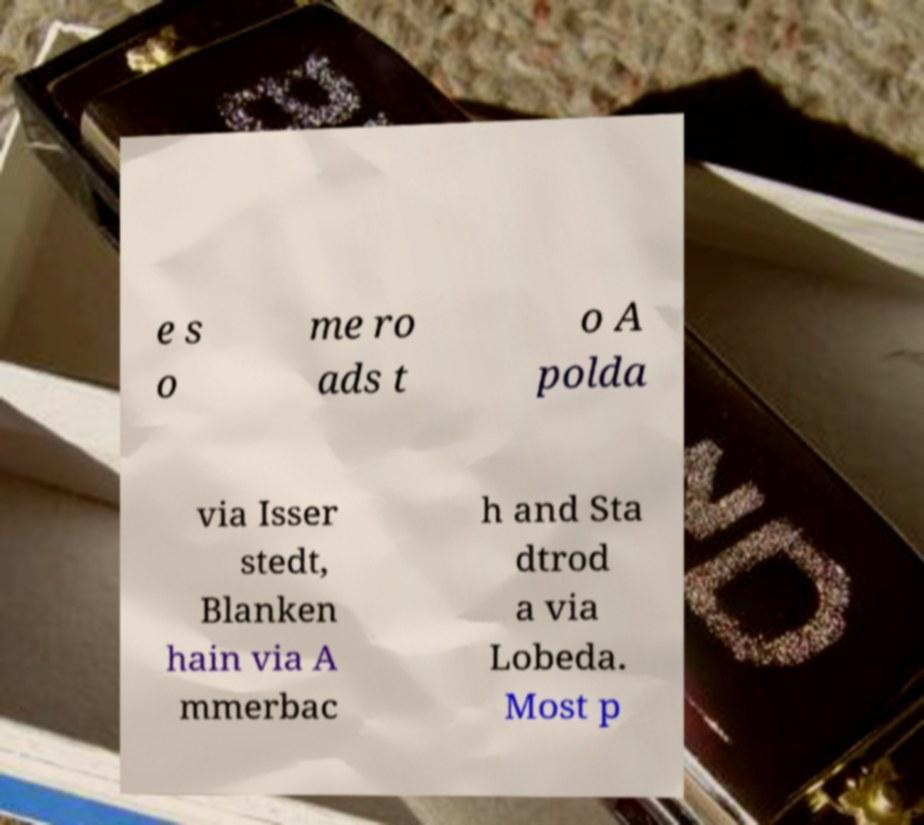Can you read and provide the text displayed in the image?This photo seems to have some interesting text. Can you extract and type it out for me? e s o me ro ads t o A polda via Isser stedt, Blanken hain via A mmerbac h and Sta dtrod a via Lobeda. Most p 